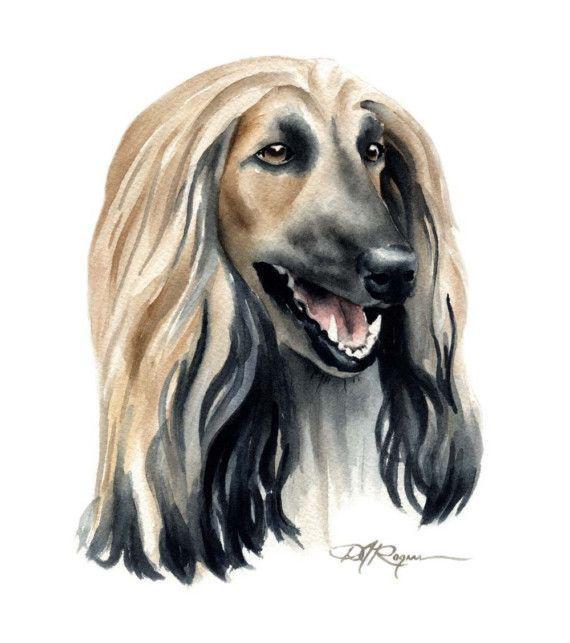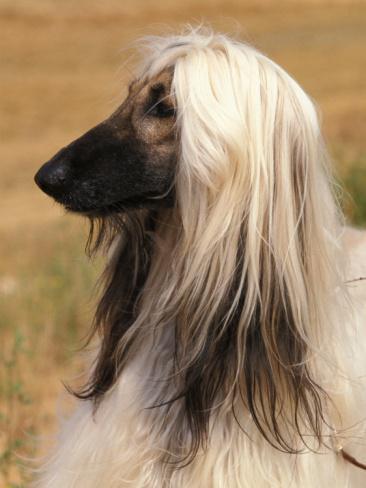The first image is the image on the left, the second image is the image on the right. Analyze the images presented: Is the assertion "One of the dogs is wearing jewelry." valid? Answer yes or no. No. The first image is the image on the left, the second image is the image on the right. For the images shown, is this caption "there us a dog wearing a necklace draped on it's neck" true? Answer yes or no. No. 